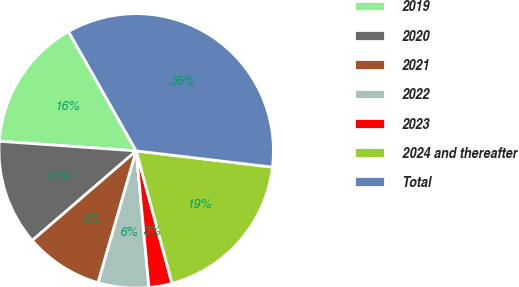Convert chart to OTSL. <chart><loc_0><loc_0><loc_500><loc_500><pie_chart><fcel>2019<fcel>2020<fcel>2021<fcel>2022<fcel>2023<fcel>2024 and thereafter<fcel>Total<nl><fcel>15.67%<fcel>12.44%<fcel>9.2%<fcel>5.96%<fcel>2.72%<fcel>18.91%<fcel>35.1%<nl></chart> 